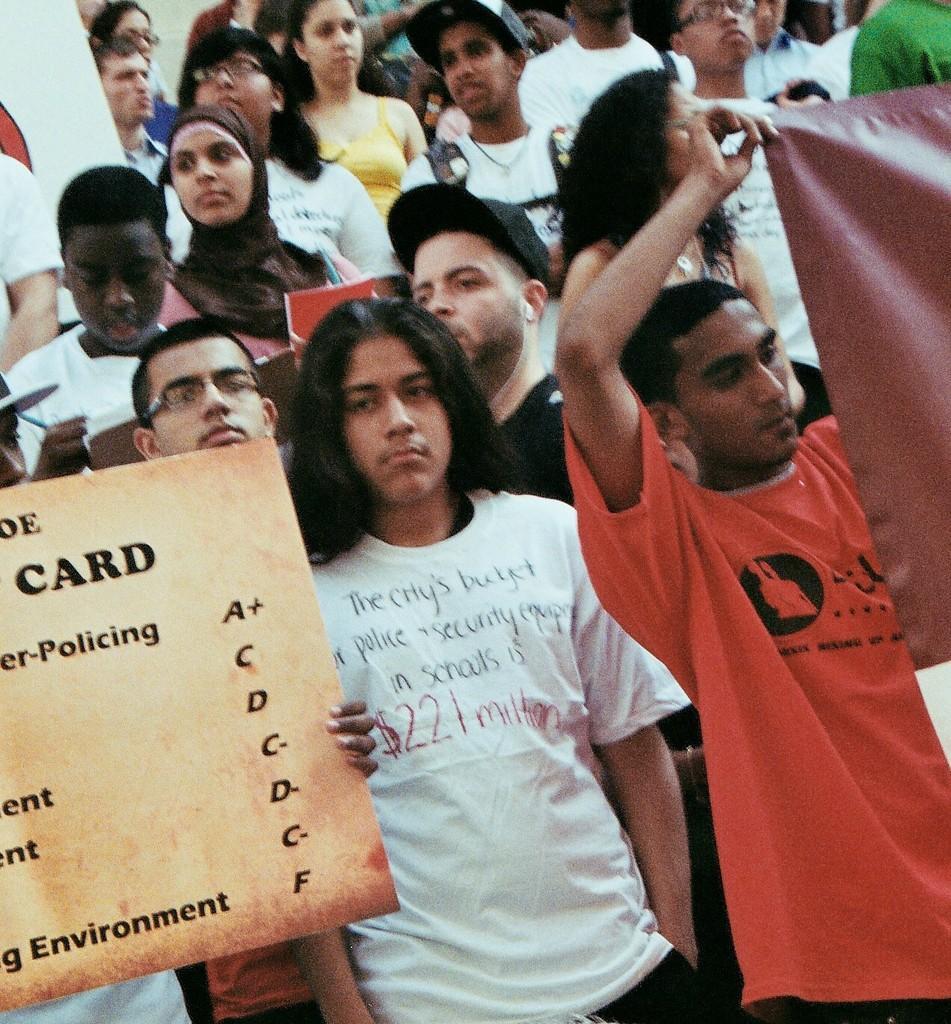Please provide a concise description of this image. In this image a group of people are standing. A few people are holding some objects. 